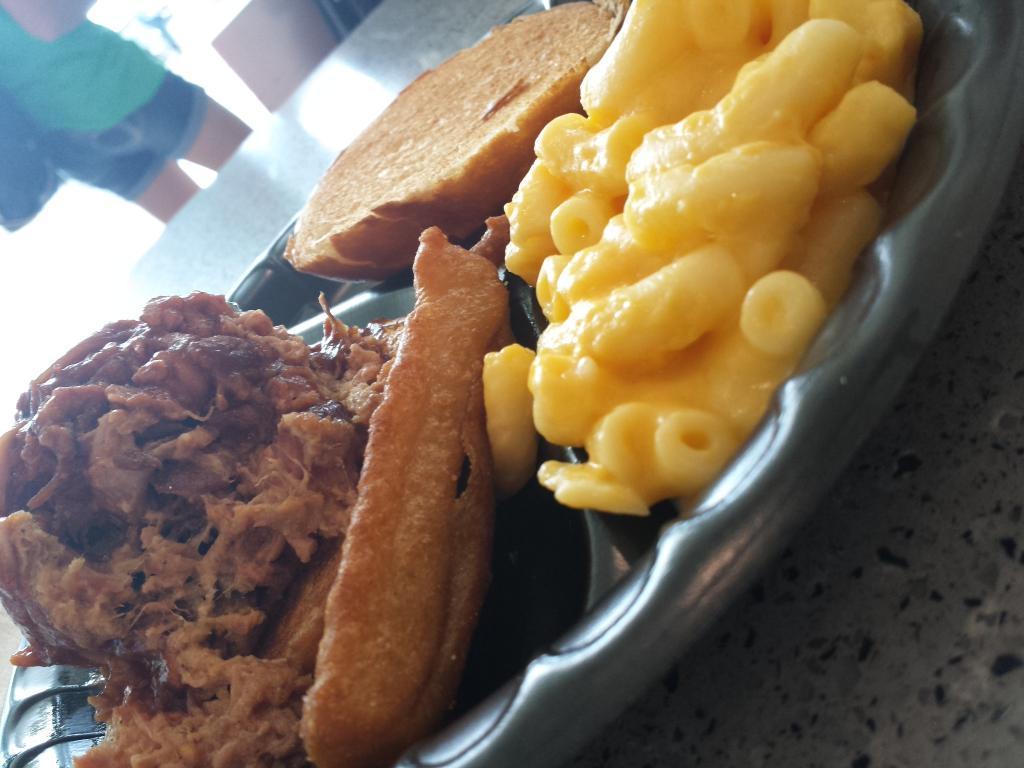Can you describe this image briefly? In this picture I can see food in the plate and I can see a table and a human in the background. 